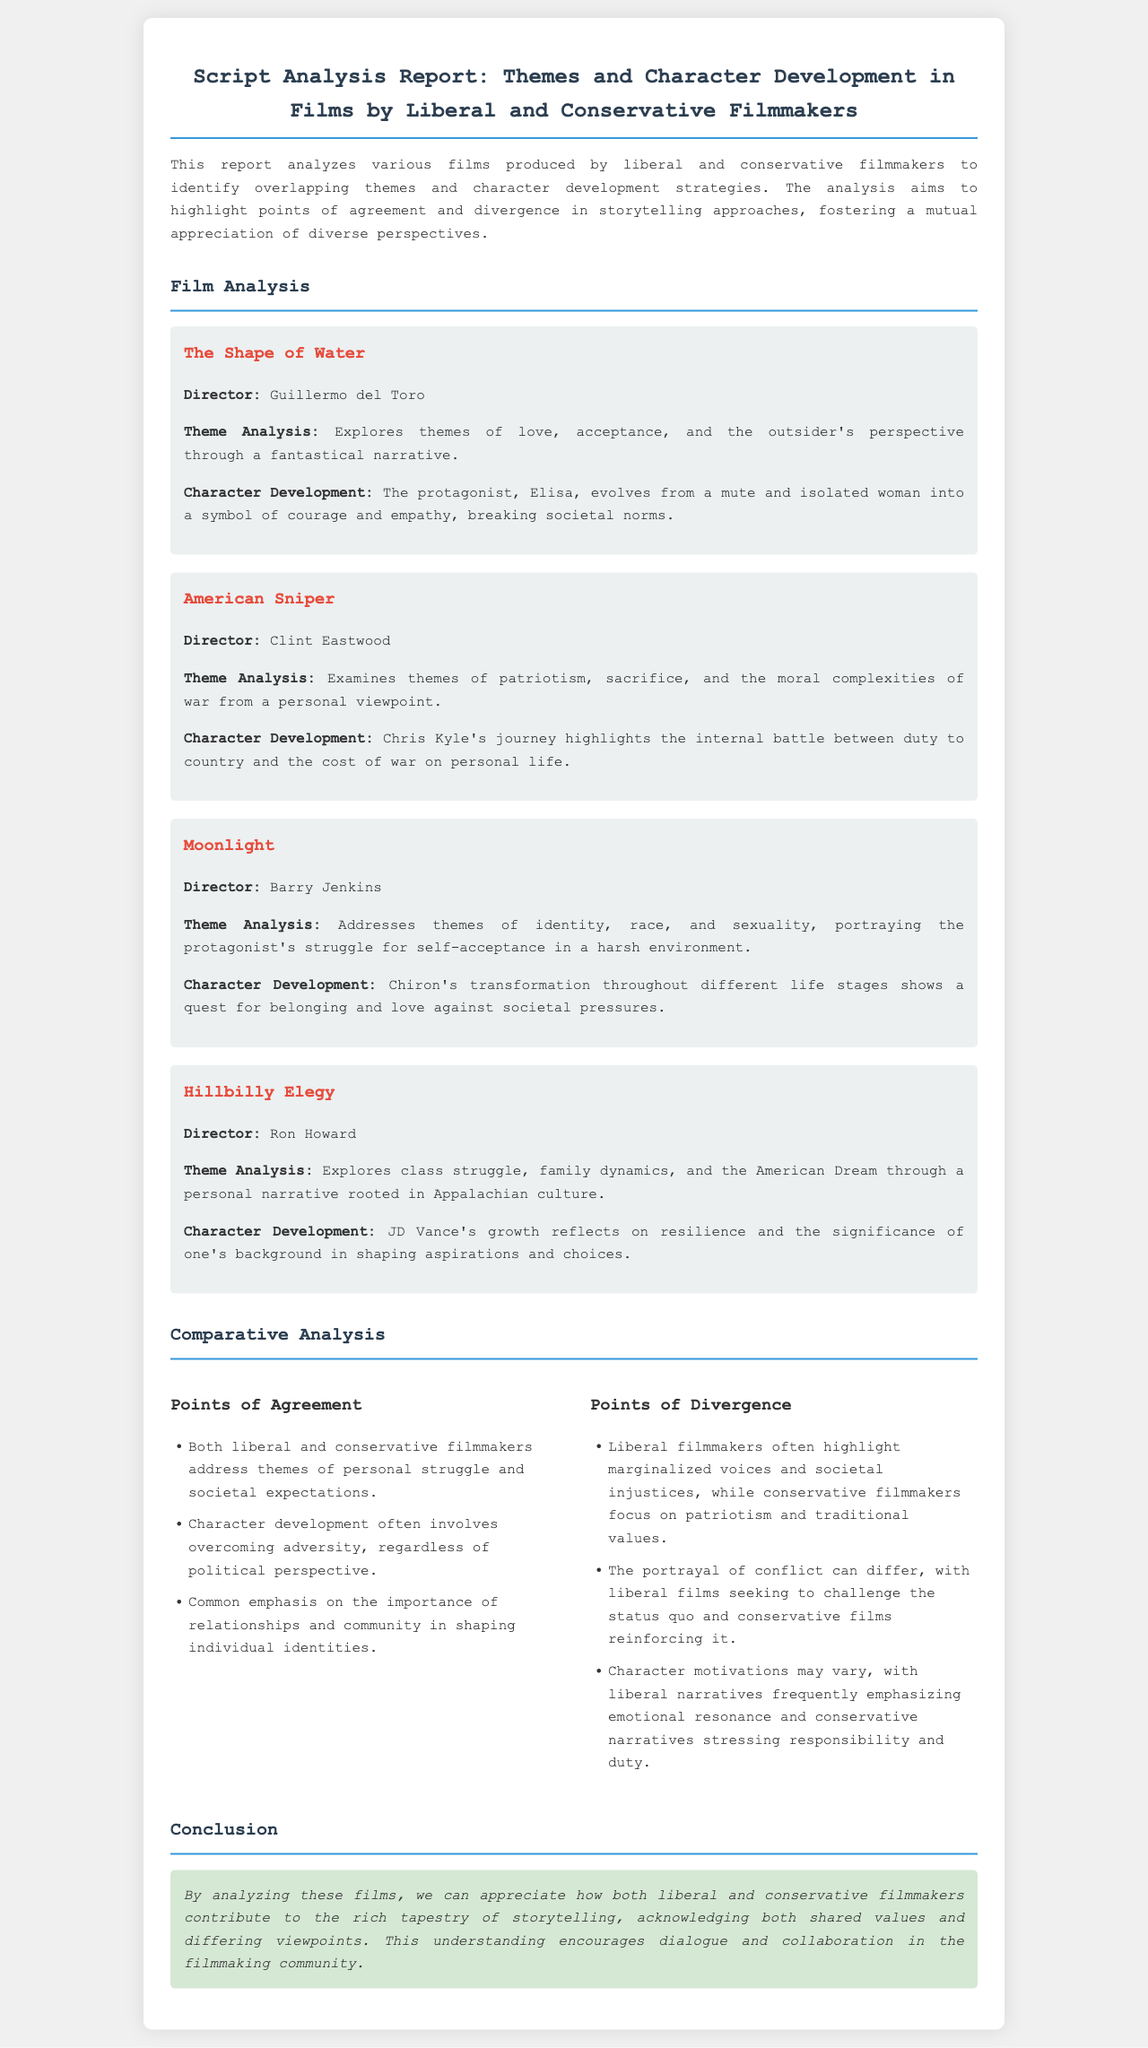What is the title of the report? The title of the report is clearly stated at the top of the document.
Answer: Script Analysis Report: Themes and Character Development in Films by Liberal and Conservative Filmmakers Who directed "The Shape of Water"? The director's name is mentioned directly under the film title.
Answer: Guillermo del Toro What theme is primarily explored in "American Sniper"? The thematic focus is summarized in the theme analysis section for the film.
Answer: Patriotism What significant character development occurs in "Moonlight"? This information is described in the character development section of the film analysis.
Answer: Quest for belonging and love How many films are analyzed in the report? The number of films analyzed can be determined by counting the film sections provided in the document.
Answer: Four What is a point of agreement between the two perspectives? Points of agreement are listed under the comparative analysis section.
Answer: Importance of relationships What is a point of divergence regarding character motivations? This information is outlined in the points of divergence in the comparative analysis section.
Answer: Emotional resonance What is the concluding theme of the report? The conclusion summarizes the overall insight derived from the film analyses.
Answer: Shared values and differing viewpoints 